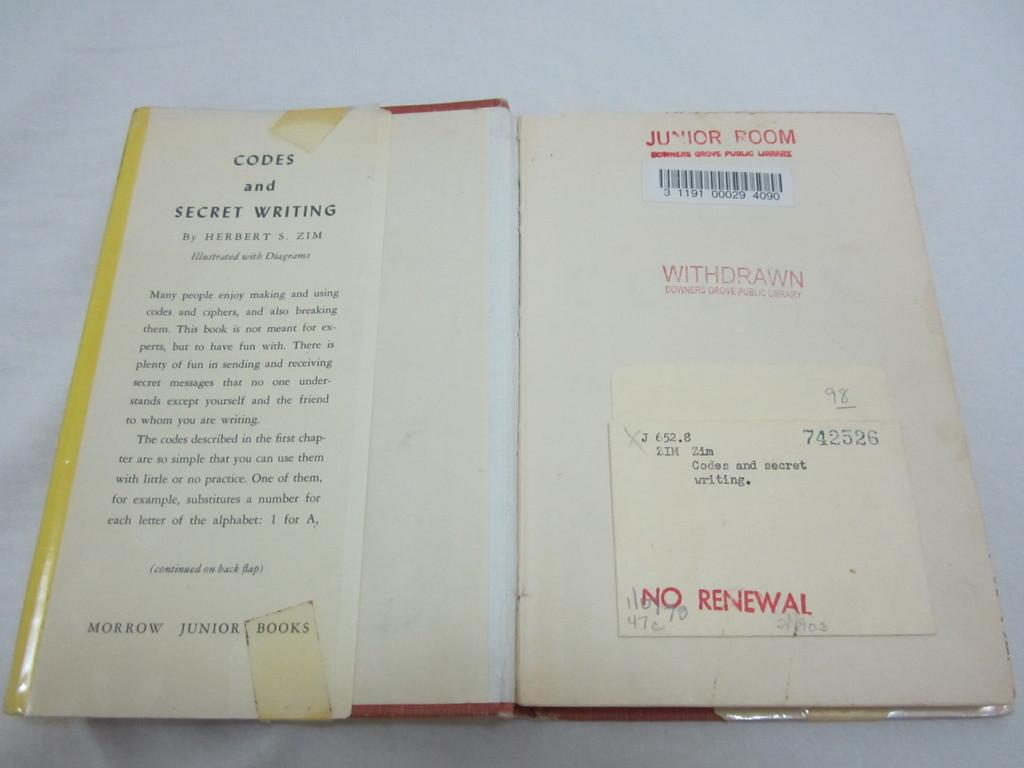<image>
Describe the image concisely. A copy of Codes and Secret Writing has been stamped with NO RENEWAL. 